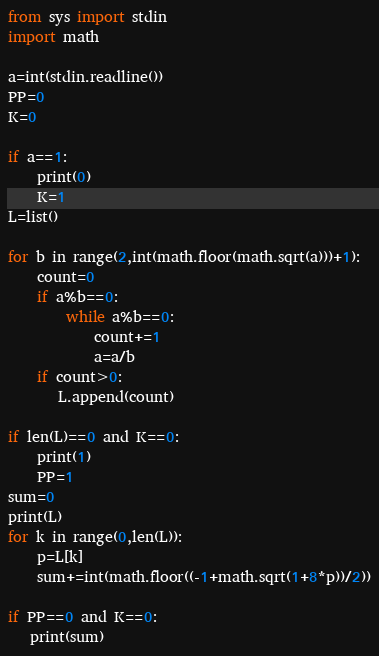Convert code to text. <code><loc_0><loc_0><loc_500><loc_500><_Python_>from sys import stdin
import math

a=int(stdin.readline())
PP=0
K=0

if a==1:
    print(0)
    K=1
L=list()

for b in range(2,int(math.floor(math.sqrt(a)))+1):
    count=0
    if a%b==0:
        while a%b==0:
            count+=1
            a=a/b
    if count>0:
       L.append(count)

if len(L)==0 and K==0:
    print(1)
    PP=1
sum=0
print(L)
for k in range(0,len(L)):
    p=L[k]
    sum+=int(math.floor((-1+math.sqrt(1+8*p))/2))

if PP==0 and K==0:
   print(sum)</code> 